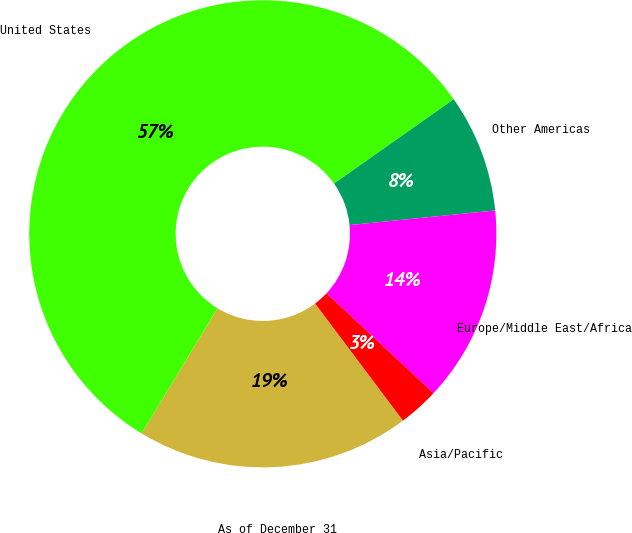<chart> <loc_0><loc_0><loc_500><loc_500><pie_chart><fcel>As of December 31<fcel>United States<fcel>Other Americas<fcel>Europe/Middle East/Africa<fcel>Asia/Pacific<nl><fcel>18.93%<fcel>56.55%<fcel>8.18%<fcel>13.55%<fcel>2.8%<nl></chart> 